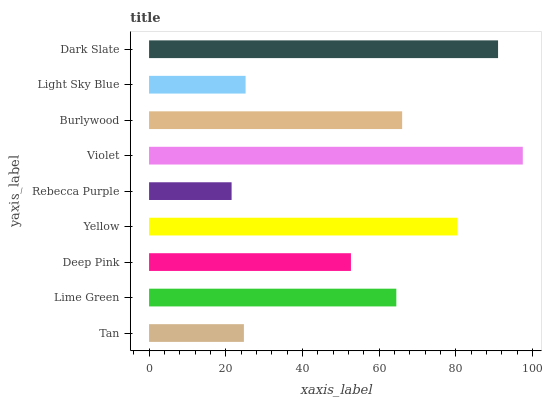Is Rebecca Purple the minimum?
Answer yes or no. Yes. Is Violet the maximum?
Answer yes or no. Yes. Is Lime Green the minimum?
Answer yes or no. No. Is Lime Green the maximum?
Answer yes or no. No. Is Lime Green greater than Tan?
Answer yes or no. Yes. Is Tan less than Lime Green?
Answer yes or no. Yes. Is Tan greater than Lime Green?
Answer yes or no. No. Is Lime Green less than Tan?
Answer yes or no. No. Is Lime Green the high median?
Answer yes or no. Yes. Is Lime Green the low median?
Answer yes or no. Yes. Is Burlywood the high median?
Answer yes or no. No. Is Violet the low median?
Answer yes or no. No. 